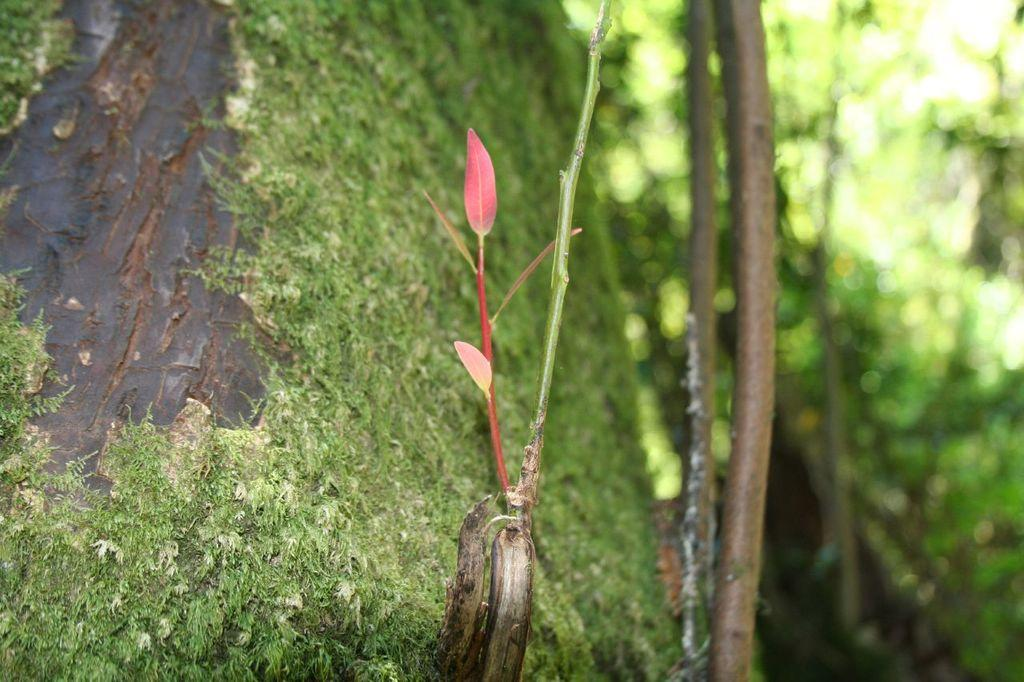What type of vegetation can be seen in the image? There is grass and trees in the image. Can you describe the natural environment depicted in the image? The image features grass and trees, which suggests a natural setting. What type of coin can be seen in the image? There is no coin present in the image; it only features grass and trees. What is the iron being used for in the image? There is no iron present in the image, as it only contains grass and trees. 